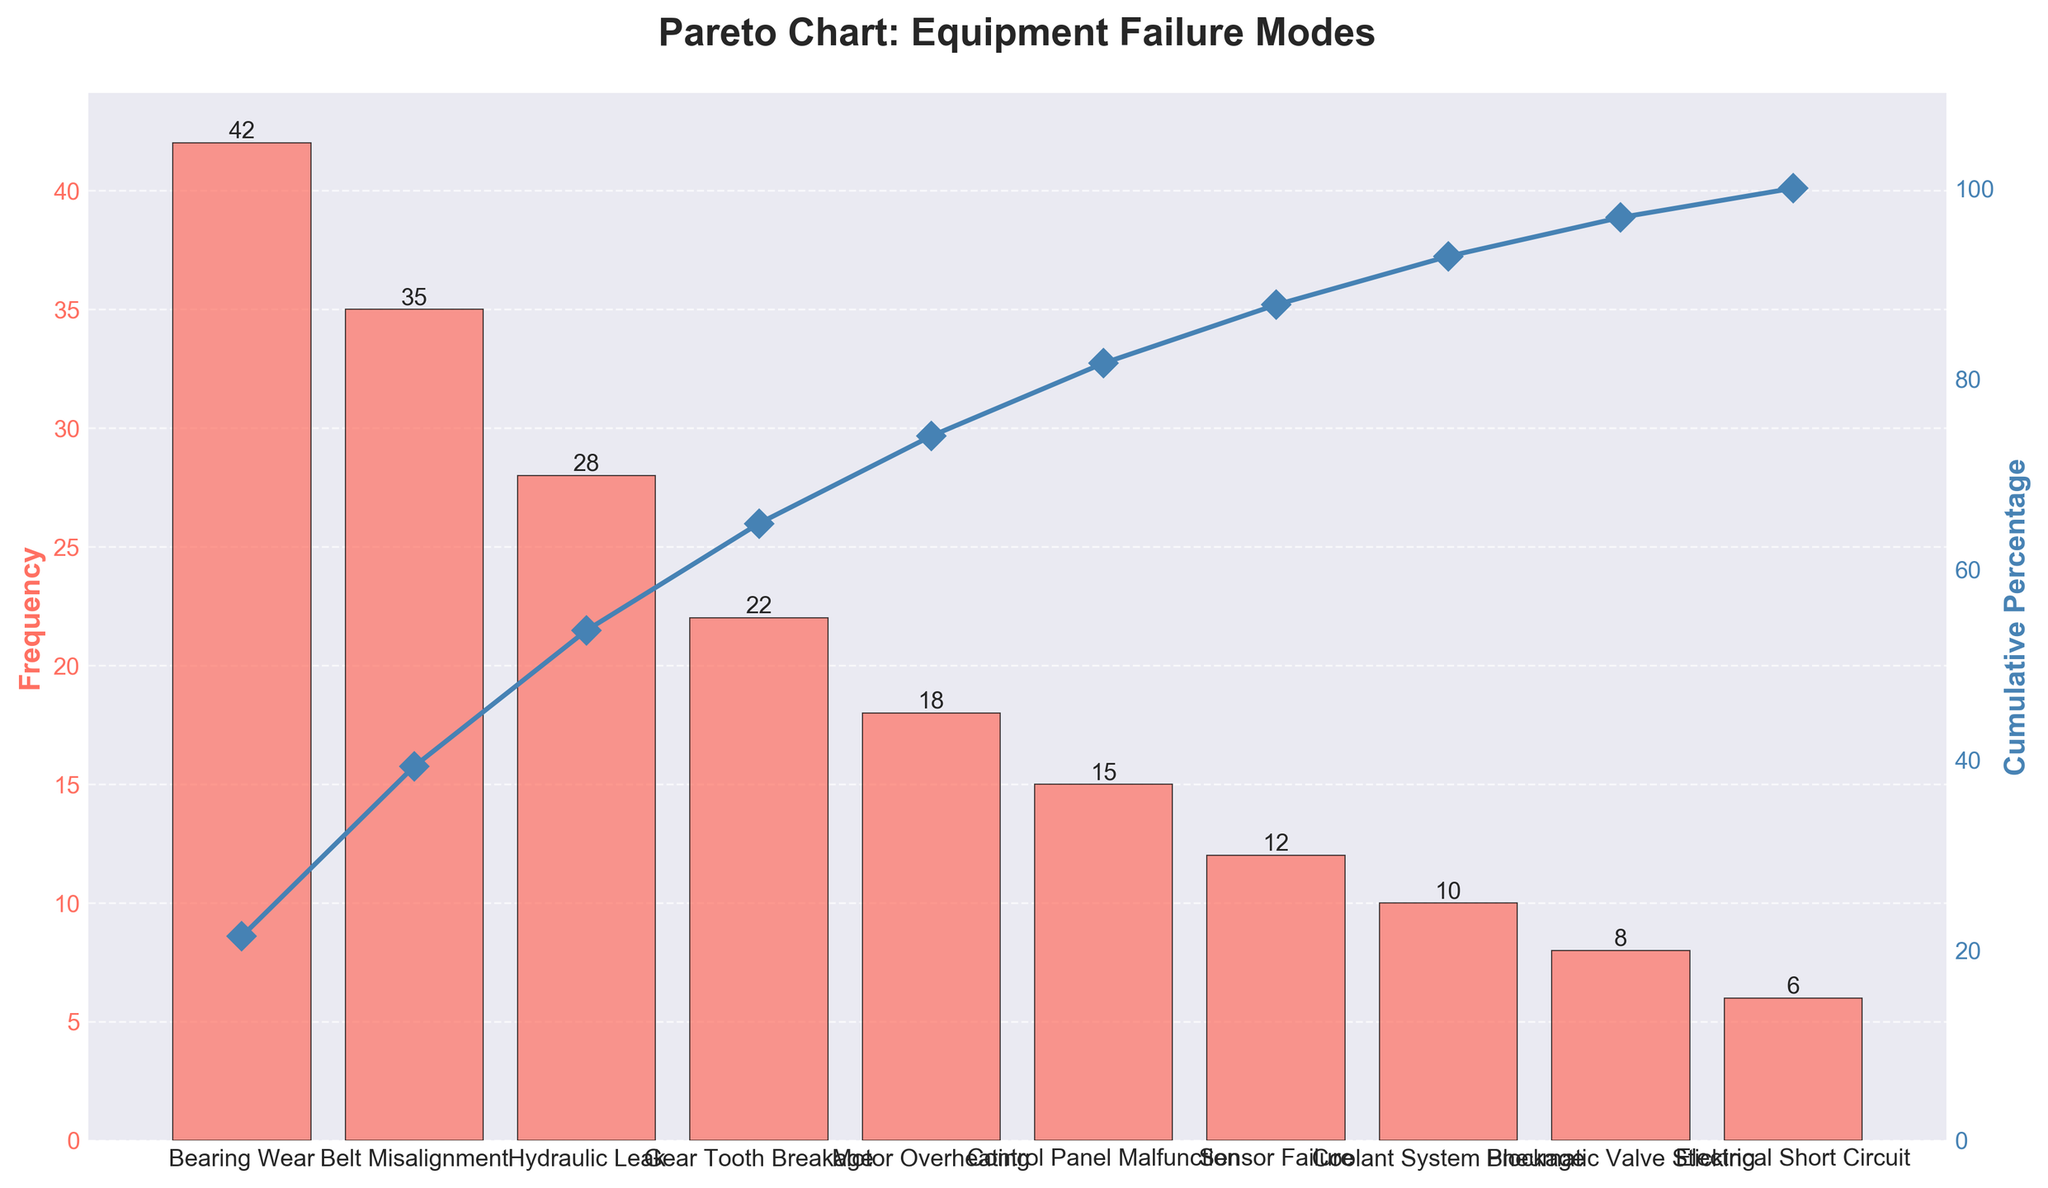What's the title of the chart? The title of the chart is usually written at the top of the figure. In this case, the title is positioned centrally at the upper part of the chart.
Answer: Pareto Chart: Equipment Failure Modes What is the failure mode with the highest frequency? Look at the height of the bars. The tallest bar corresponds to the highest frequency.
Answer: Bearing Wear What is the cumulative percentage after the second failure mode? The cumulative percentage line plot provides the cumulative values after each failure mode. The second point on this line is what we need.
Answer: 48.3% Which failure mode has the highest downtime impact? The chart does not directly show downtime impact, but the data list and the graph together allow us to identify it. The "Gear Tooth Breakage" mode is mentioned in the data as having the highest downtime impact.
Answer: Gear Tooth Breakage What is the frequency of Hydraulic Leak? Check the height of the bar labeled "Hydraulic Leak" and read the value provided above the bar.
Answer: 28 What are the cumulative percentages after Belt Misalignment and Hydraulic Leak combined? Sum their frequencies: 35 + 28 = 63. Then calculate the cumulative percentage: 63 / 196 * 100 = 32.1%. Starting from zero, count the cumulative percentages provided in the chart segment by segment to reach this value after Belt Misalignment and including Hydraulic Leak.
Answer: 47.9% How many modes have a frequency higher than 20? Count the bars that are taller than the 20 mark on the Frequency axis.
Answer: 4 What is the total frequency of the three least frequent failure modes? Add the frequencies of the three shortest bars: 12 (Sensor Failure) + 10 (Coolant System Blockage) + 8 (Pneumatic Valve Sticking) = 30.
Answer: 30 Which failure modes contribute to a cumulative percentage of more than 70%? Track the points along the cumulative percentage curve and check which failure modes cumulatively result in a value exceeding 70%.
Answer: Bearing Wear, Belt Misalignment, Hydraulic Leak How does the cumulative percentage change between Motor Overheating and Control Panel Malfunction? The cumulative percentage rises gradually between these two failure modes, as indicated by the difference in height from one point on the cumulative percentage line to the next. Calculate the difference directly: around 89.8% - 77.6% = 12.2%.
Answer: 12.2% 